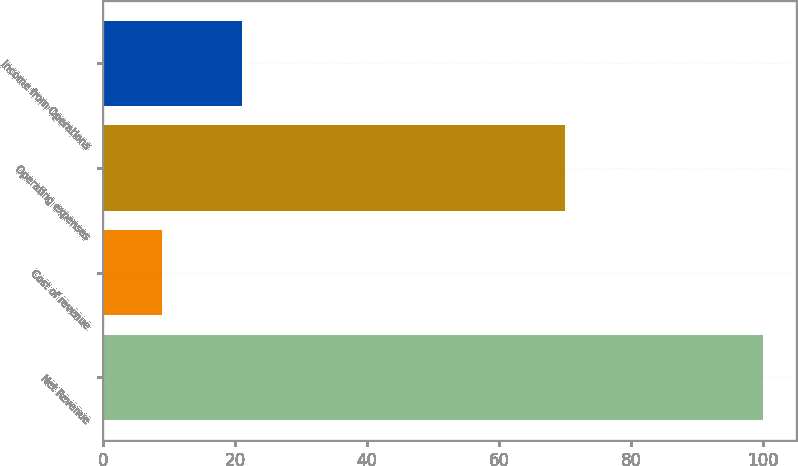<chart> <loc_0><loc_0><loc_500><loc_500><bar_chart><fcel>Net Revenue<fcel>Cost of revenue<fcel>Operating expenses<fcel>Income from Operations<nl><fcel>100<fcel>9<fcel>70<fcel>21<nl></chart> 